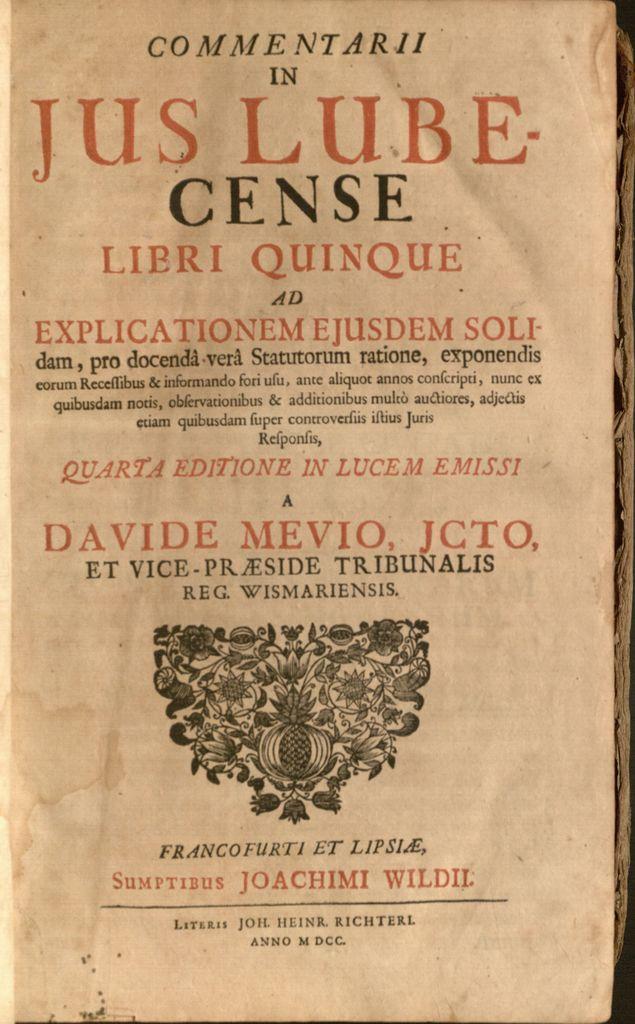Who is the author of this book?
Give a very brief answer. Joachimi wildil. 